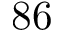Convert formula to latex. <formula><loc_0><loc_0><loc_500><loc_500>8 6</formula> 